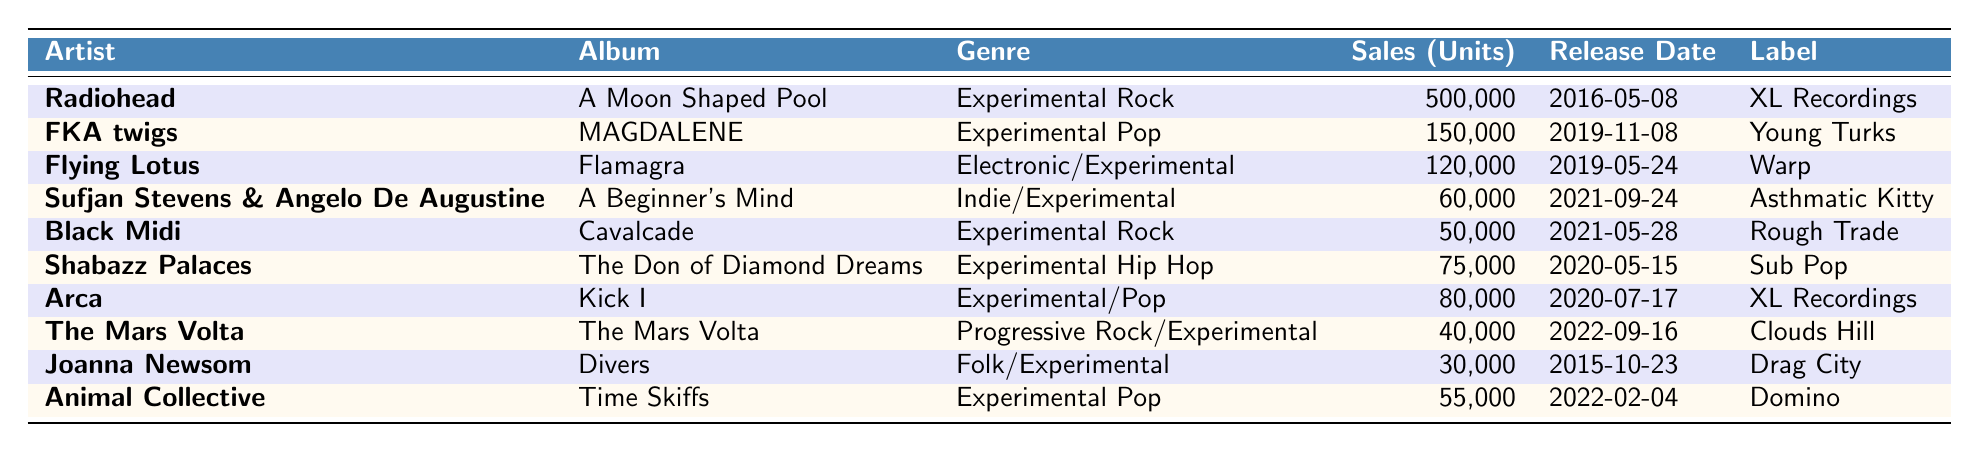What is the highest-selling album in this table? The highest-selling album can be found by looking at the "Sales (Units)" column. The album "A Moon Shaped Pool" by Radiohead has the highest sales figure of 500,000 units.
Answer: 500,000 units Which artist has the lowest sales from the table? To find the artist with the lowest sales, we can examine the "Sales (Units)" column. The lowest sale is for the album "Divers" by Joanna Newsom with 30,000 units sold.
Answer: Joanna Newsom How many total units were sold across all albums in the table? We can calculate the total by summing the sales figures for all albums listed in the table: 500,000 + 150,000 + 120,000 + 60,000 + 50,000 + 75,000 + 80,000 + 40,000 + 30,000 + 55,000 = 1,110,000 units.
Answer: 1,110,000 units What is the average sales across the albums listed? First, we sum the sales figures: 1,110,000 units. There are 10 albums in total, so we divide the total sales by the number of albums to get the average: 1,110,000 / 10 = 111,000 units.
Answer: 111,000 units Is there a genre that has sold more than 100,000 units? By examining the "Sales (Units)" column, we see that only "A Moon Shaped Pool" has sales exceeding 100,000 units, confirming there's one album in that category.
Answer: Yes Which genres have albums released in 2022? In the table, we look for the "Release Date" column and find that "The Mars Volta" and "Time Skiffs" have release dates in 2022. Thus, the genres represented are "Progressive Rock/Experimental" and "Experimental Pop."
Answer: Progressive Rock/Experimental and Experimental Pop What are the total sales of Experimental Pop albums in the table? We check the "Genre" column for "Experimental Pop" and find two albums: "MAGDALENE" by FKA twigs (150,000) and "Time Skiffs" by Animal Collective (55,000). Adding these gives us 150,000 + 55,000 = 205,000 units.
Answer: 205,000 units Which album was released first: "Cavalcade" by Black Midi or "Flamagra" by Flying Lotus? The assignment requires checking the dates in the "Release Date" column. "Flamagra" was released on 2019-05-24 and "Cavalcade" on 2021-05-28, indicating "Flamagra" was released first.
Answer: Flamagra What label released the album with the highest sales? The highest sales belong to "A Moon Shaped Pool" which was released by XL Recordings, as noted in the "Label" column.
Answer: XL Recordings How many albums in the table are classified under "Experimental Rock"? In the "Genre" column, we can see that there are two albums listed under "Experimental Rock": "A Moon Shaped Pool" and "Cavalcade" by Black Midi. Thus, there are 2 albums.
Answer: 2 albums 